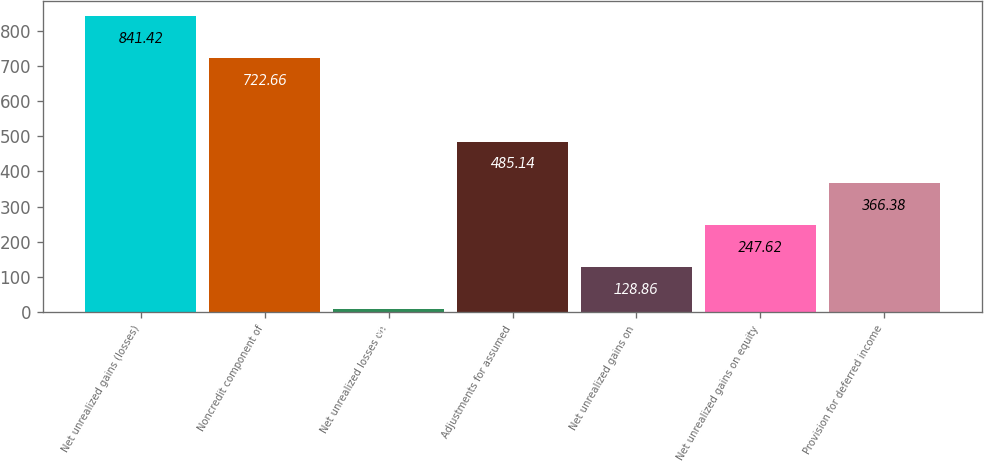<chart> <loc_0><loc_0><loc_500><loc_500><bar_chart><fcel>Net unrealized gains (losses)<fcel>Noncredit component of<fcel>Net unrealized losses on<fcel>Adjustments for assumed<fcel>Net unrealized gains on<fcel>Net unrealized gains on equity<fcel>Provision for deferred income<nl><fcel>841.42<fcel>722.66<fcel>10.1<fcel>485.14<fcel>128.86<fcel>247.62<fcel>366.38<nl></chart> 